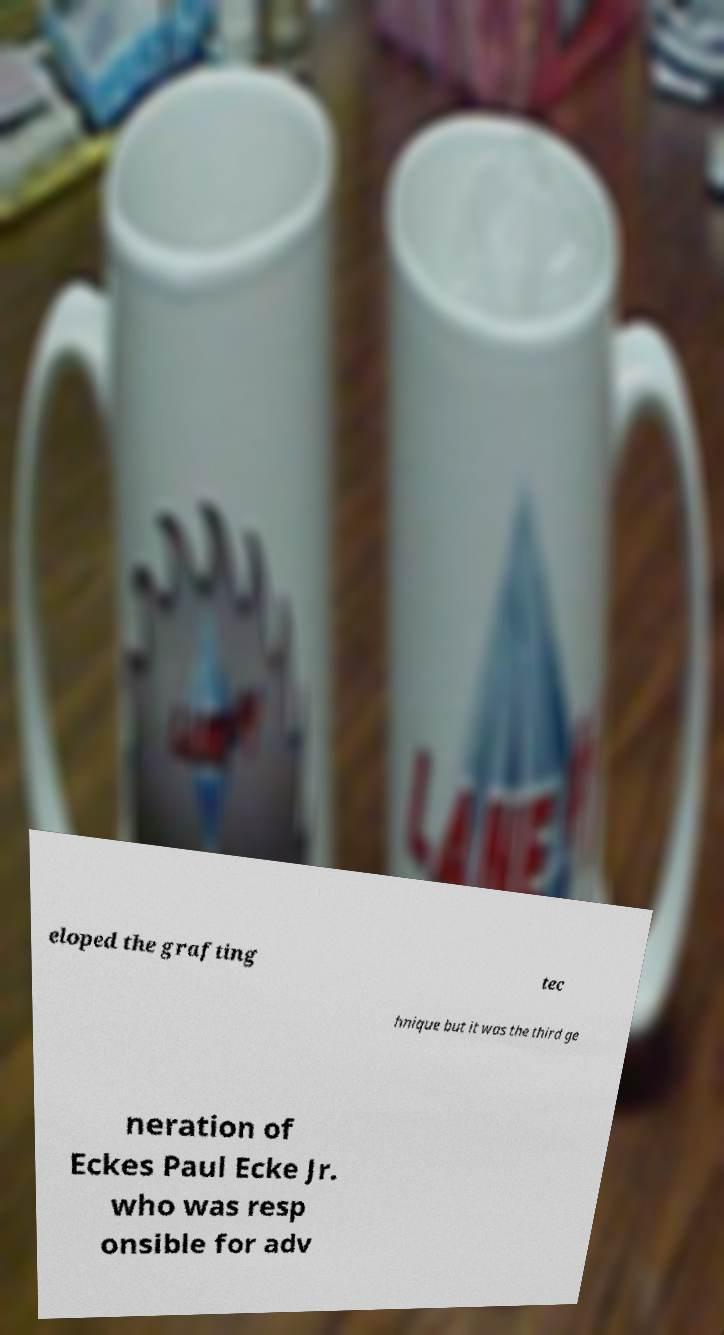I need the written content from this picture converted into text. Can you do that? eloped the grafting tec hnique but it was the third ge neration of Eckes Paul Ecke Jr. who was resp onsible for adv 